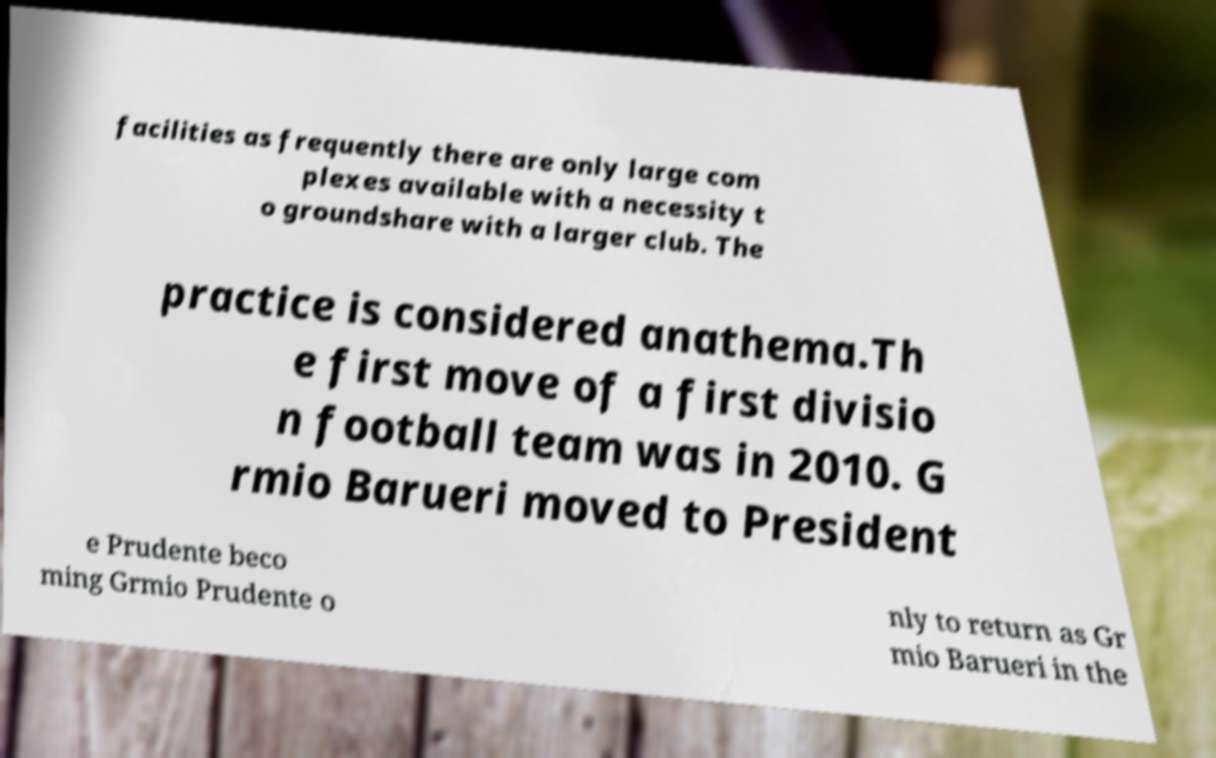Could you extract and type out the text from this image? facilities as frequently there are only large com plexes available with a necessity t o groundshare with a larger club. The practice is considered anathema.Th e first move of a first divisio n football team was in 2010. G rmio Barueri moved to President e Prudente beco ming Grmio Prudente o nly to return as Gr mio Barueri in the 